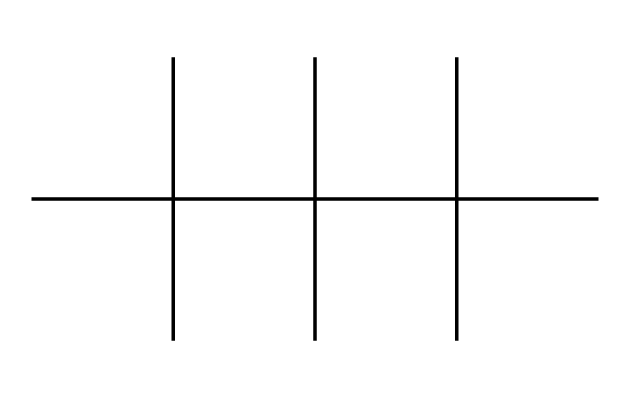What is the main functional group present in this polymer? The structure reveals primarily carbon atoms connected in a branched formation; because there are no other atoms like oxygen or nitrogen, it suggests that the functional groups are aliphatic hydrocarbons. Thus, it can be classified under the category of linear or branched polymers without specific functional groups.
Answer: aliphatic hydrocarbons How many carbon atoms are in this molecular structure? The given SMILES representation indicates a fully carbon-based structure with branched components. Counting the 'C' in the structure leads to a total of 18 carbon atoms present in this polymer.
Answer: 18 What type of polymer is indicated by this chemical structure? The structure shows a large number of carbon atoms and the absence of heteroatoms, indicating it is a polyolefin type of polymer. The branched structure suggests it is a thermoplastic elastomer, typically derived from ethylene, propylene, or their derivatives.
Answer: polyolefin What is the average degree of branching in this polymer? The branching can be determined by visualizing how many branches are present per carbon chain length compared to linear polymers. In this case, there are numerous branched groups along with a main chain, indicating a high degree of branching, specifically noting multiple tertiary carbon centers.
Answer: high How does the molecular structure affect the physical properties of the polymer? The highly branched structure enhances flexibility and lowers the density of the polymer. Compared to linear polymers, branched ones exhibit better tensile strength and impact resistance because the structural arrangement allows for more energy absorption during deformation.
Answer: enhanced flexibility Which type of applications would benefit from this polymer's properties? The flexibility and durability due to its branching make it ideal for applications like microphone coatings, where resistance to wear and tear is essential without compromising sound quality or elasticity.
Answer: microphone coatings 